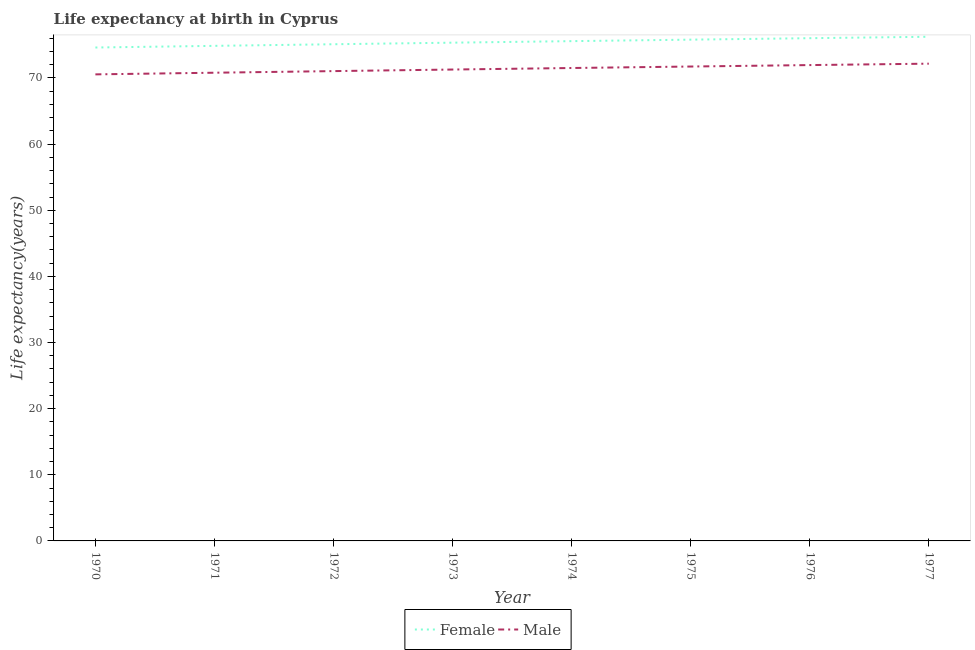How many different coloured lines are there?
Your answer should be compact. 2. Is the number of lines equal to the number of legend labels?
Your answer should be compact. Yes. What is the life expectancy(male) in 1977?
Provide a succinct answer. 72.16. Across all years, what is the maximum life expectancy(female)?
Your answer should be compact. 76.23. Across all years, what is the minimum life expectancy(female)?
Your answer should be very brief. 74.6. In which year was the life expectancy(female) maximum?
Give a very brief answer. 1977. In which year was the life expectancy(female) minimum?
Your answer should be compact. 1970. What is the total life expectancy(female) in the graph?
Your response must be concise. 603.49. What is the difference between the life expectancy(male) in 1972 and that in 1977?
Ensure brevity in your answer.  -1.12. What is the difference between the life expectancy(male) in 1974 and the life expectancy(female) in 1971?
Make the answer very short. -3.35. What is the average life expectancy(male) per year?
Make the answer very short. 71.37. In the year 1974, what is the difference between the life expectancy(female) and life expectancy(male)?
Provide a short and direct response. 4.06. In how many years, is the life expectancy(female) greater than 24 years?
Your response must be concise. 8. What is the ratio of the life expectancy(female) in 1970 to that in 1975?
Offer a terse response. 0.98. Is the life expectancy(female) in 1972 less than that in 1975?
Ensure brevity in your answer.  Yes. Is the difference between the life expectancy(female) in 1971 and 1974 greater than the difference between the life expectancy(male) in 1971 and 1974?
Ensure brevity in your answer.  No. What is the difference between the highest and the second highest life expectancy(male)?
Your response must be concise. 0.21. What is the difference between the highest and the lowest life expectancy(female)?
Offer a very short reply. 1.63. In how many years, is the life expectancy(female) greater than the average life expectancy(female) taken over all years?
Your answer should be very brief. 4. Is the sum of the life expectancy(male) in 1975 and 1976 greater than the maximum life expectancy(female) across all years?
Give a very brief answer. Yes. How many lines are there?
Provide a succinct answer. 2. What is the difference between two consecutive major ticks on the Y-axis?
Make the answer very short. 10. Does the graph contain grids?
Offer a very short reply. No. How are the legend labels stacked?
Provide a succinct answer. Horizontal. What is the title of the graph?
Provide a succinct answer. Life expectancy at birth in Cyprus. Does "Urban" appear as one of the legend labels in the graph?
Give a very brief answer. No. What is the label or title of the X-axis?
Your response must be concise. Year. What is the label or title of the Y-axis?
Provide a succinct answer. Life expectancy(years). What is the Life expectancy(years) in Female in 1970?
Give a very brief answer. 74.6. What is the Life expectancy(years) of Male in 1970?
Your answer should be very brief. 70.54. What is the Life expectancy(years) in Female in 1971?
Keep it short and to the point. 74.85. What is the Life expectancy(years) in Male in 1971?
Keep it short and to the point. 70.79. What is the Life expectancy(years) in Female in 1972?
Make the answer very short. 75.1. What is the Life expectancy(years) of Male in 1972?
Provide a succinct answer. 71.04. What is the Life expectancy(years) in Female in 1973?
Your response must be concise. 75.33. What is the Life expectancy(years) in Male in 1973?
Your response must be concise. 71.27. What is the Life expectancy(years) of Female in 1974?
Provide a succinct answer. 75.57. What is the Life expectancy(years) in Male in 1974?
Your answer should be compact. 71.5. What is the Life expectancy(years) of Female in 1975?
Make the answer very short. 75.79. What is the Life expectancy(years) of Male in 1975?
Provide a succinct answer. 71.73. What is the Life expectancy(years) in Female in 1976?
Provide a short and direct response. 76.01. What is the Life expectancy(years) in Male in 1976?
Ensure brevity in your answer.  71.95. What is the Life expectancy(years) in Female in 1977?
Provide a succinct answer. 76.23. What is the Life expectancy(years) of Male in 1977?
Offer a very short reply. 72.16. Across all years, what is the maximum Life expectancy(years) of Female?
Make the answer very short. 76.23. Across all years, what is the maximum Life expectancy(years) of Male?
Your answer should be very brief. 72.16. Across all years, what is the minimum Life expectancy(years) in Female?
Keep it short and to the point. 74.6. Across all years, what is the minimum Life expectancy(years) in Male?
Provide a succinct answer. 70.54. What is the total Life expectancy(years) of Female in the graph?
Your answer should be very brief. 603.49. What is the total Life expectancy(years) of Male in the graph?
Your answer should be compact. 570.98. What is the difference between the Life expectancy(years) of Female in 1970 and that in 1971?
Ensure brevity in your answer.  -0.25. What is the difference between the Life expectancy(years) of Female in 1970 and that in 1972?
Your answer should be very brief. -0.49. What is the difference between the Life expectancy(years) of Male in 1970 and that in 1972?
Make the answer very short. -0.49. What is the difference between the Life expectancy(years) in Female in 1970 and that in 1973?
Your answer should be very brief. -0.73. What is the difference between the Life expectancy(years) in Male in 1970 and that in 1973?
Your response must be concise. -0.73. What is the difference between the Life expectancy(years) of Female in 1970 and that in 1974?
Ensure brevity in your answer.  -0.96. What is the difference between the Life expectancy(years) of Male in 1970 and that in 1974?
Make the answer very short. -0.96. What is the difference between the Life expectancy(years) of Female in 1970 and that in 1975?
Offer a very short reply. -1.19. What is the difference between the Life expectancy(years) of Male in 1970 and that in 1975?
Ensure brevity in your answer.  -1.19. What is the difference between the Life expectancy(years) in Female in 1970 and that in 1976?
Offer a terse response. -1.41. What is the difference between the Life expectancy(years) in Male in 1970 and that in 1976?
Provide a short and direct response. -1.41. What is the difference between the Life expectancy(years) of Female in 1970 and that in 1977?
Your answer should be very brief. -1.63. What is the difference between the Life expectancy(years) of Male in 1970 and that in 1977?
Your answer should be very brief. -1.62. What is the difference between the Life expectancy(years) of Female in 1971 and that in 1972?
Offer a very short reply. -0.24. What is the difference between the Life expectancy(years) of Male in 1971 and that in 1972?
Offer a very short reply. -0.24. What is the difference between the Life expectancy(years) of Female in 1971 and that in 1973?
Offer a very short reply. -0.48. What is the difference between the Life expectancy(years) of Male in 1971 and that in 1973?
Provide a short and direct response. -0.48. What is the difference between the Life expectancy(years) in Female in 1971 and that in 1974?
Provide a succinct answer. -0.71. What is the difference between the Life expectancy(years) in Male in 1971 and that in 1974?
Your answer should be compact. -0.71. What is the difference between the Life expectancy(years) in Female in 1971 and that in 1975?
Give a very brief answer. -0.94. What is the difference between the Life expectancy(years) of Male in 1971 and that in 1975?
Your answer should be compact. -0.94. What is the difference between the Life expectancy(years) of Female in 1971 and that in 1976?
Offer a very short reply. -1.16. What is the difference between the Life expectancy(years) of Male in 1971 and that in 1976?
Ensure brevity in your answer.  -1.16. What is the difference between the Life expectancy(years) of Female in 1971 and that in 1977?
Offer a very short reply. -1.38. What is the difference between the Life expectancy(years) of Male in 1971 and that in 1977?
Offer a very short reply. -1.37. What is the difference between the Life expectancy(years) of Female in 1972 and that in 1973?
Provide a short and direct response. -0.24. What is the difference between the Life expectancy(years) in Male in 1972 and that in 1973?
Provide a succinct answer. -0.24. What is the difference between the Life expectancy(years) in Female in 1972 and that in 1974?
Give a very brief answer. -0.47. What is the difference between the Life expectancy(years) of Male in 1972 and that in 1974?
Provide a succinct answer. -0.47. What is the difference between the Life expectancy(years) of Female in 1972 and that in 1975?
Offer a very short reply. -0.69. What is the difference between the Life expectancy(years) in Male in 1972 and that in 1975?
Your answer should be compact. -0.69. What is the difference between the Life expectancy(years) in Female in 1972 and that in 1976?
Your response must be concise. -0.92. What is the difference between the Life expectancy(years) of Male in 1972 and that in 1976?
Offer a very short reply. -0.91. What is the difference between the Life expectancy(years) in Female in 1972 and that in 1977?
Offer a very short reply. -1.13. What is the difference between the Life expectancy(years) in Male in 1972 and that in 1977?
Your answer should be compact. -1.12. What is the difference between the Life expectancy(years) in Female in 1973 and that in 1974?
Keep it short and to the point. -0.23. What is the difference between the Life expectancy(years) in Male in 1973 and that in 1974?
Your answer should be compact. -0.23. What is the difference between the Life expectancy(years) of Female in 1973 and that in 1975?
Provide a succinct answer. -0.46. What is the difference between the Life expectancy(years) of Male in 1973 and that in 1975?
Ensure brevity in your answer.  -0.46. What is the difference between the Life expectancy(years) in Female in 1973 and that in 1976?
Offer a very short reply. -0.68. What is the difference between the Life expectancy(years) of Male in 1973 and that in 1976?
Offer a terse response. -0.67. What is the difference between the Life expectancy(years) of Female in 1973 and that in 1977?
Offer a terse response. -0.89. What is the difference between the Life expectancy(years) in Male in 1973 and that in 1977?
Offer a very short reply. -0.89. What is the difference between the Life expectancy(years) of Female in 1974 and that in 1975?
Your answer should be very brief. -0.23. What is the difference between the Life expectancy(years) of Male in 1974 and that in 1975?
Make the answer very short. -0.22. What is the difference between the Life expectancy(years) in Female in 1974 and that in 1976?
Make the answer very short. -0.45. What is the difference between the Life expectancy(years) of Male in 1974 and that in 1976?
Offer a terse response. -0.44. What is the difference between the Life expectancy(years) of Female in 1974 and that in 1977?
Keep it short and to the point. -0.66. What is the difference between the Life expectancy(years) in Male in 1974 and that in 1977?
Offer a terse response. -0.66. What is the difference between the Life expectancy(years) of Female in 1975 and that in 1976?
Provide a short and direct response. -0.22. What is the difference between the Life expectancy(years) in Male in 1975 and that in 1976?
Make the answer very short. -0.22. What is the difference between the Life expectancy(years) of Female in 1975 and that in 1977?
Your answer should be compact. -0.44. What is the difference between the Life expectancy(years) in Male in 1975 and that in 1977?
Ensure brevity in your answer.  -0.43. What is the difference between the Life expectancy(years) of Female in 1976 and that in 1977?
Your response must be concise. -0.22. What is the difference between the Life expectancy(years) in Male in 1976 and that in 1977?
Provide a succinct answer. -0.21. What is the difference between the Life expectancy(years) in Female in 1970 and the Life expectancy(years) in Male in 1971?
Your answer should be very brief. 3.81. What is the difference between the Life expectancy(years) in Female in 1970 and the Life expectancy(years) in Male in 1972?
Your answer should be compact. 3.57. What is the difference between the Life expectancy(years) in Female in 1970 and the Life expectancy(years) in Male in 1973?
Your answer should be very brief. 3.33. What is the difference between the Life expectancy(years) in Female in 1970 and the Life expectancy(years) in Male in 1974?
Make the answer very short. 3.1. What is the difference between the Life expectancy(years) of Female in 1970 and the Life expectancy(years) of Male in 1975?
Make the answer very short. 2.88. What is the difference between the Life expectancy(years) in Female in 1970 and the Life expectancy(years) in Male in 1976?
Offer a very short reply. 2.66. What is the difference between the Life expectancy(years) of Female in 1970 and the Life expectancy(years) of Male in 1977?
Make the answer very short. 2.44. What is the difference between the Life expectancy(years) of Female in 1971 and the Life expectancy(years) of Male in 1972?
Ensure brevity in your answer.  3.82. What is the difference between the Life expectancy(years) in Female in 1971 and the Life expectancy(years) in Male in 1973?
Offer a terse response. 3.58. What is the difference between the Life expectancy(years) of Female in 1971 and the Life expectancy(years) of Male in 1974?
Provide a succinct answer. 3.35. What is the difference between the Life expectancy(years) in Female in 1971 and the Life expectancy(years) in Male in 1975?
Your answer should be very brief. 3.12. What is the difference between the Life expectancy(years) in Female in 1971 and the Life expectancy(years) in Male in 1976?
Offer a terse response. 2.91. What is the difference between the Life expectancy(years) in Female in 1971 and the Life expectancy(years) in Male in 1977?
Your response must be concise. 2.69. What is the difference between the Life expectancy(years) of Female in 1972 and the Life expectancy(years) of Male in 1973?
Keep it short and to the point. 3.82. What is the difference between the Life expectancy(years) in Female in 1972 and the Life expectancy(years) in Male in 1974?
Keep it short and to the point. 3.59. What is the difference between the Life expectancy(years) of Female in 1972 and the Life expectancy(years) of Male in 1975?
Make the answer very short. 3.37. What is the difference between the Life expectancy(years) of Female in 1972 and the Life expectancy(years) of Male in 1976?
Provide a short and direct response. 3.15. What is the difference between the Life expectancy(years) in Female in 1972 and the Life expectancy(years) in Male in 1977?
Ensure brevity in your answer.  2.94. What is the difference between the Life expectancy(years) in Female in 1973 and the Life expectancy(years) in Male in 1974?
Your response must be concise. 3.83. What is the difference between the Life expectancy(years) of Female in 1973 and the Life expectancy(years) of Male in 1975?
Ensure brevity in your answer.  3.61. What is the difference between the Life expectancy(years) in Female in 1973 and the Life expectancy(years) in Male in 1976?
Your answer should be compact. 3.39. What is the difference between the Life expectancy(years) in Female in 1973 and the Life expectancy(years) in Male in 1977?
Your answer should be very brief. 3.17. What is the difference between the Life expectancy(years) in Female in 1974 and the Life expectancy(years) in Male in 1975?
Provide a succinct answer. 3.84. What is the difference between the Life expectancy(years) in Female in 1974 and the Life expectancy(years) in Male in 1976?
Make the answer very short. 3.62. What is the difference between the Life expectancy(years) in Female in 1974 and the Life expectancy(years) in Male in 1977?
Provide a short and direct response. 3.41. What is the difference between the Life expectancy(years) of Female in 1975 and the Life expectancy(years) of Male in 1976?
Make the answer very short. 3.85. What is the difference between the Life expectancy(years) in Female in 1975 and the Life expectancy(years) in Male in 1977?
Your answer should be compact. 3.63. What is the difference between the Life expectancy(years) in Female in 1976 and the Life expectancy(years) in Male in 1977?
Offer a very short reply. 3.85. What is the average Life expectancy(years) in Female per year?
Your answer should be compact. 75.44. What is the average Life expectancy(years) in Male per year?
Offer a very short reply. 71.37. In the year 1970, what is the difference between the Life expectancy(years) of Female and Life expectancy(years) of Male?
Offer a terse response. 4.06. In the year 1971, what is the difference between the Life expectancy(years) in Female and Life expectancy(years) in Male?
Your answer should be compact. 4.06. In the year 1972, what is the difference between the Life expectancy(years) of Female and Life expectancy(years) of Male?
Give a very brief answer. 4.06. In the year 1973, what is the difference between the Life expectancy(years) of Female and Life expectancy(years) of Male?
Provide a short and direct response. 4.06. In the year 1974, what is the difference between the Life expectancy(years) of Female and Life expectancy(years) of Male?
Keep it short and to the point. 4.06. In the year 1975, what is the difference between the Life expectancy(years) in Female and Life expectancy(years) in Male?
Give a very brief answer. 4.06. In the year 1976, what is the difference between the Life expectancy(years) of Female and Life expectancy(years) of Male?
Offer a very short reply. 4.07. In the year 1977, what is the difference between the Life expectancy(years) in Female and Life expectancy(years) in Male?
Your answer should be very brief. 4.07. What is the ratio of the Life expectancy(years) in Female in 1970 to that in 1971?
Give a very brief answer. 1. What is the ratio of the Life expectancy(years) in Male in 1970 to that in 1971?
Give a very brief answer. 1. What is the ratio of the Life expectancy(years) of Male in 1970 to that in 1972?
Provide a succinct answer. 0.99. What is the ratio of the Life expectancy(years) of Female in 1970 to that in 1973?
Make the answer very short. 0.99. What is the ratio of the Life expectancy(years) in Male in 1970 to that in 1973?
Your response must be concise. 0.99. What is the ratio of the Life expectancy(years) in Female in 1970 to that in 1974?
Provide a short and direct response. 0.99. What is the ratio of the Life expectancy(years) in Male in 1970 to that in 1974?
Your answer should be compact. 0.99. What is the ratio of the Life expectancy(years) in Female in 1970 to that in 1975?
Your answer should be compact. 0.98. What is the ratio of the Life expectancy(years) in Male in 1970 to that in 1975?
Your answer should be very brief. 0.98. What is the ratio of the Life expectancy(years) in Female in 1970 to that in 1976?
Provide a short and direct response. 0.98. What is the ratio of the Life expectancy(years) in Male in 1970 to that in 1976?
Offer a terse response. 0.98. What is the ratio of the Life expectancy(years) in Female in 1970 to that in 1977?
Ensure brevity in your answer.  0.98. What is the ratio of the Life expectancy(years) in Male in 1970 to that in 1977?
Offer a very short reply. 0.98. What is the ratio of the Life expectancy(years) of Male in 1971 to that in 1972?
Give a very brief answer. 1. What is the ratio of the Life expectancy(years) of Female in 1971 to that in 1974?
Provide a short and direct response. 0.99. What is the ratio of the Life expectancy(years) in Female in 1971 to that in 1975?
Ensure brevity in your answer.  0.99. What is the ratio of the Life expectancy(years) in Female in 1971 to that in 1976?
Your answer should be compact. 0.98. What is the ratio of the Life expectancy(years) of Male in 1971 to that in 1976?
Keep it short and to the point. 0.98. What is the ratio of the Life expectancy(years) of Female in 1971 to that in 1977?
Offer a terse response. 0.98. What is the ratio of the Life expectancy(years) of Male in 1971 to that in 1977?
Keep it short and to the point. 0.98. What is the ratio of the Life expectancy(years) in Female in 1972 to that in 1973?
Offer a terse response. 1. What is the ratio of the Life expectancy(years) in Male in 1972 to that in 1973?
Provide a short and direct response. 1. What is the ratio of the Life expectancy(years) in Female in 1972 to that in 1974?
Provide a succinct answer. 0.99. What is the ratio of the Life expectancy(years) in Male in 1972 to that in 1974?
Your answer should be compact. 0.99. What is the ratio of the Life expectancy(years) in Female in 1972 to that in 1976?
Your response must be concise. 0.99. What is the ratio of the Life expectancy(years) of Male in 1972 to that in 1976?
Ensure brevity in your answer.  0.99. What is the ratio of the Life expectancy(years) in Female in 1972 to that in 1977?
Offer a terse response. 0.99. What is the ratio of the Life expectancy(years) in Male in 1972 to that in 1977?
Offer a very short reply. 0.98. What is the ratio of the Life expectancy(years) in Female in 1973 to that in 1974?
Ensure brevity in your answer.  1. What is the ratio of the Life expectancy(years) of Male in 1973 to that in 1974?
Offer a terse response. 1. What is the ratio of the Life expectancy(years) of Female in 1973 to that in 1975?
Offer a very short reply. 0.99. What is the ratio of the Life expectancy(years) of Male in 1973 to that in 1975?
Give a very brief answer. 0.99. What is the ratio of the Life expectancy(years) in Female in 1973 to that in 1976?
Give a very brief answer. 0.99. What is the ratio of the Life expectancy(years) of Male in 1973 to that in 1976?
Your answer should be very brief. 0.99. What is the ratio of the Life expectancy(years) in Female in 1973 to that in 1977?
Offer a terse response. 0.99. What is the ratio of the Life expectancy(years) in Female in 1974 to that in 1976?
Your answer should be very brief. 0.99. What is the ratio of the Life expectancy(years) in Female in 1974 to that in 1977?
Offer a terse response. 0.99. What is the ratio of the Life expectancy(years) of Male in 1974 to that in 1977?
Your response must be concise. 0.99. What is the ratio of the Life expectancy(years) in Male in 1975 to that in 1976?
Provide a short and direct response. 1. What is the ratio of the Life expectancy(years) of Male in 1975 to that in 1977?
Ensure brevity in your answer.  0.99. What is the ratio of the Life expectancy(years) in Male in 1976 to that in 1977?
Your response must be concise. 1. What is the difference between the highest and the second highest Life expectancy(years) in Female?
Ensure brevity in your answer.  0.22. What is the difference between the highest and the second highest Life expectancy(years) in Male?
Your answer should be compact. 0.21. What is the difference between the highest and the lowest Life expectancy(years) in Female?
Make the answer very short. 1.63. What is the difference between the highest and the lowest Life expectancy(years) of Male?
Offer a terse response. 1.62. 